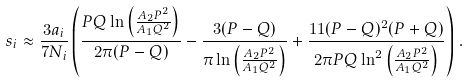<formula> <loc_0><loc_0><loc_500><loc_500>s _ { i } \approx \frac { 3 a _ { i } } { 7 N _ { i } } \left ( \frac { P Q \ln \left ( \frac { A _ { 2 } P ^ { 2 } } { A _ { 1 } Q ^ { 2 } } \right ) } { 2 \pi ( P - Q ) } - \frac { 3 ( P - Q ) } { \pi \ln \left ( \frac { A _ { 2 } P ^ { 2 } } { A _ { 1 } Q ^ { 2 } } \right ) } + \frac { 1 1 ( P - Q ) ^ { 2 } ( P + Q ) } { 2 \pi P Q \ln ^ { 2 } \left ( \frac { A _ { 2 } P ^ { 2 } } { A _ { 1 } Q ^ { 2 } } \right ) } \right ) \, .</formula> 